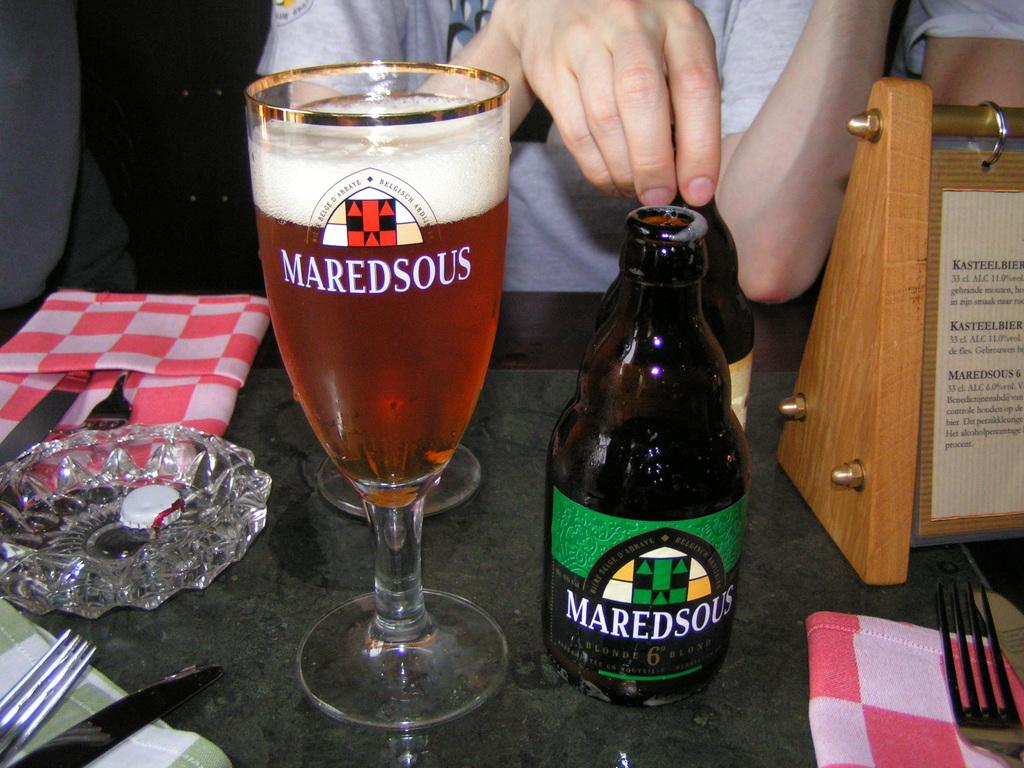<image>
Write a terse but informative summary of the picture. A glass of Maredsous, with the bottle next to it. 